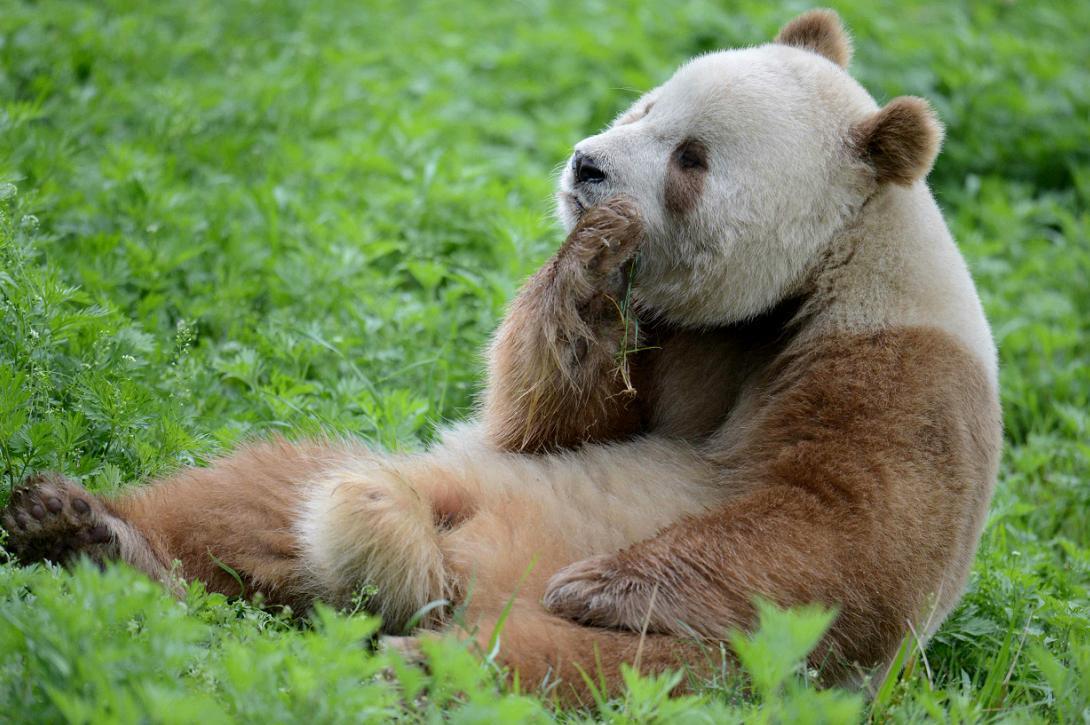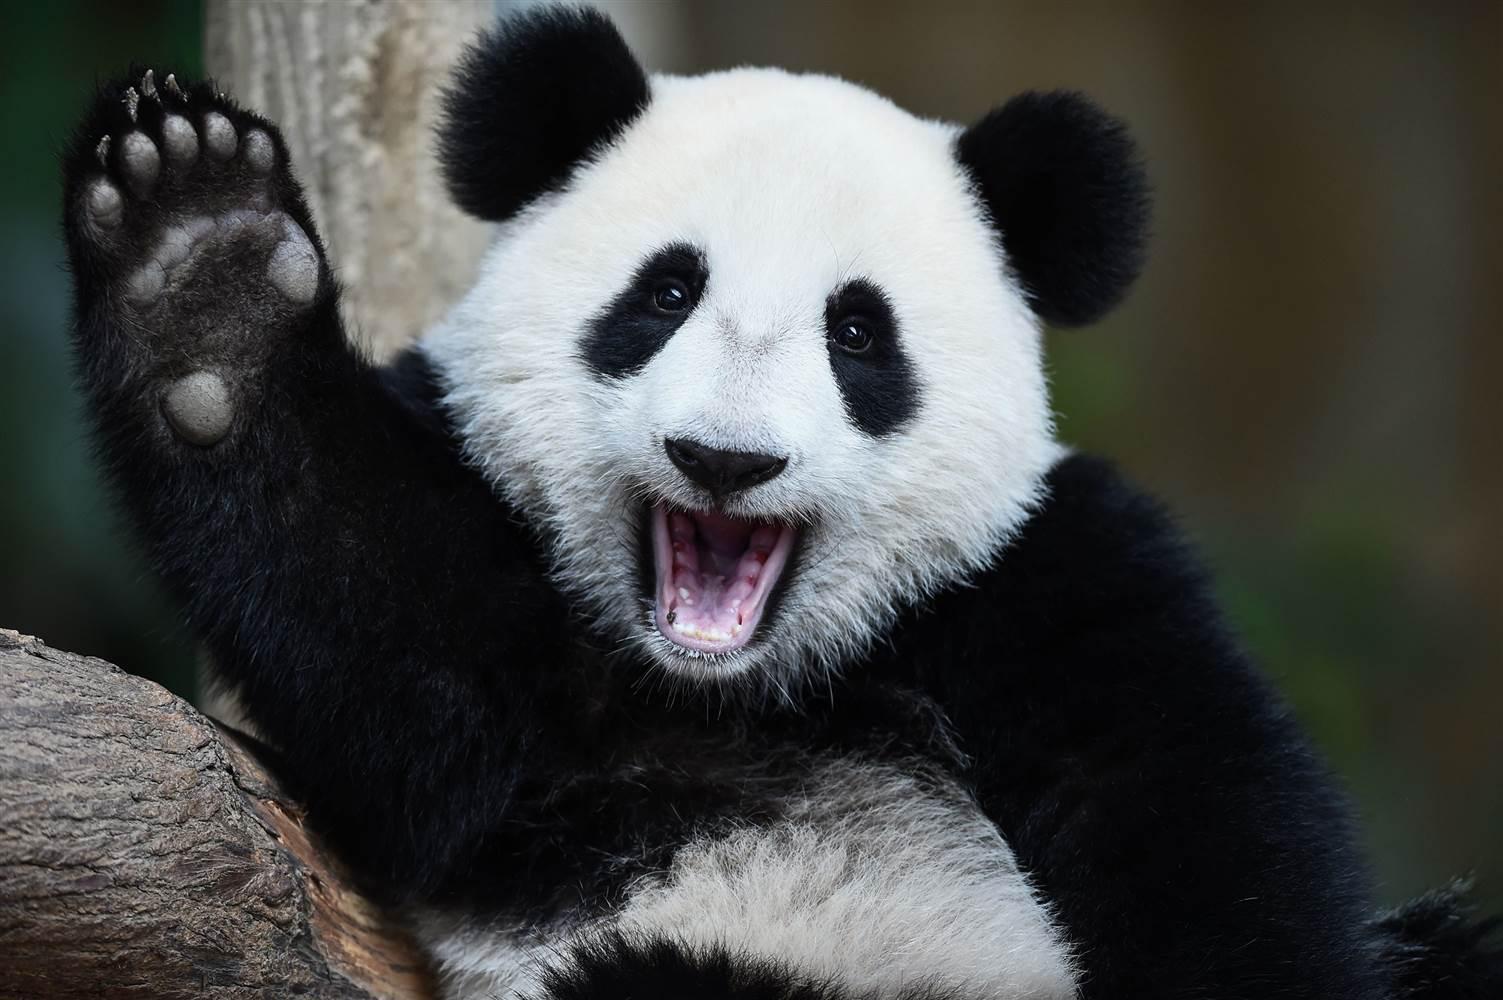The first image is the image on the left, the second image is the image on the right. Examine the images to the left and right. Is the description "An image includes a panda at least partly lying on its back on green ground." accurate? Answer yes or no. Yes. The first image is the image on the left, the second image is the image on the right. For the images shown, is this caption "The panda on the left is in a tree." true? Answer yes or no. No. 